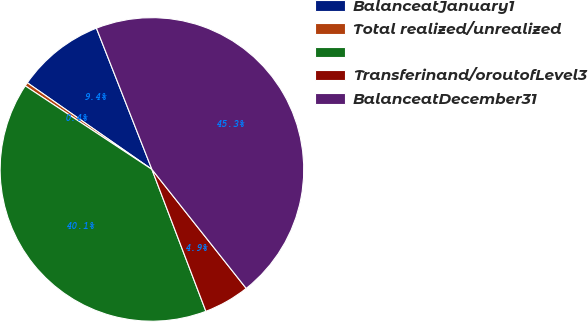Convert chart. <chart><loc_0><loc_0><loc_500><loc_500><pie_chart><fcel>BalanceatJanuary1<fcel>Total realized/unrealized<fcel>Unnamed: 2<fcel>Transferinand/oroutofLevel3<fcel>BalanceatDecember31<nl><fcel>9.37%<fcel>0.39%<fcel>40.07%<fcel>4.88%<fcel>45.3%<nl></chart> 